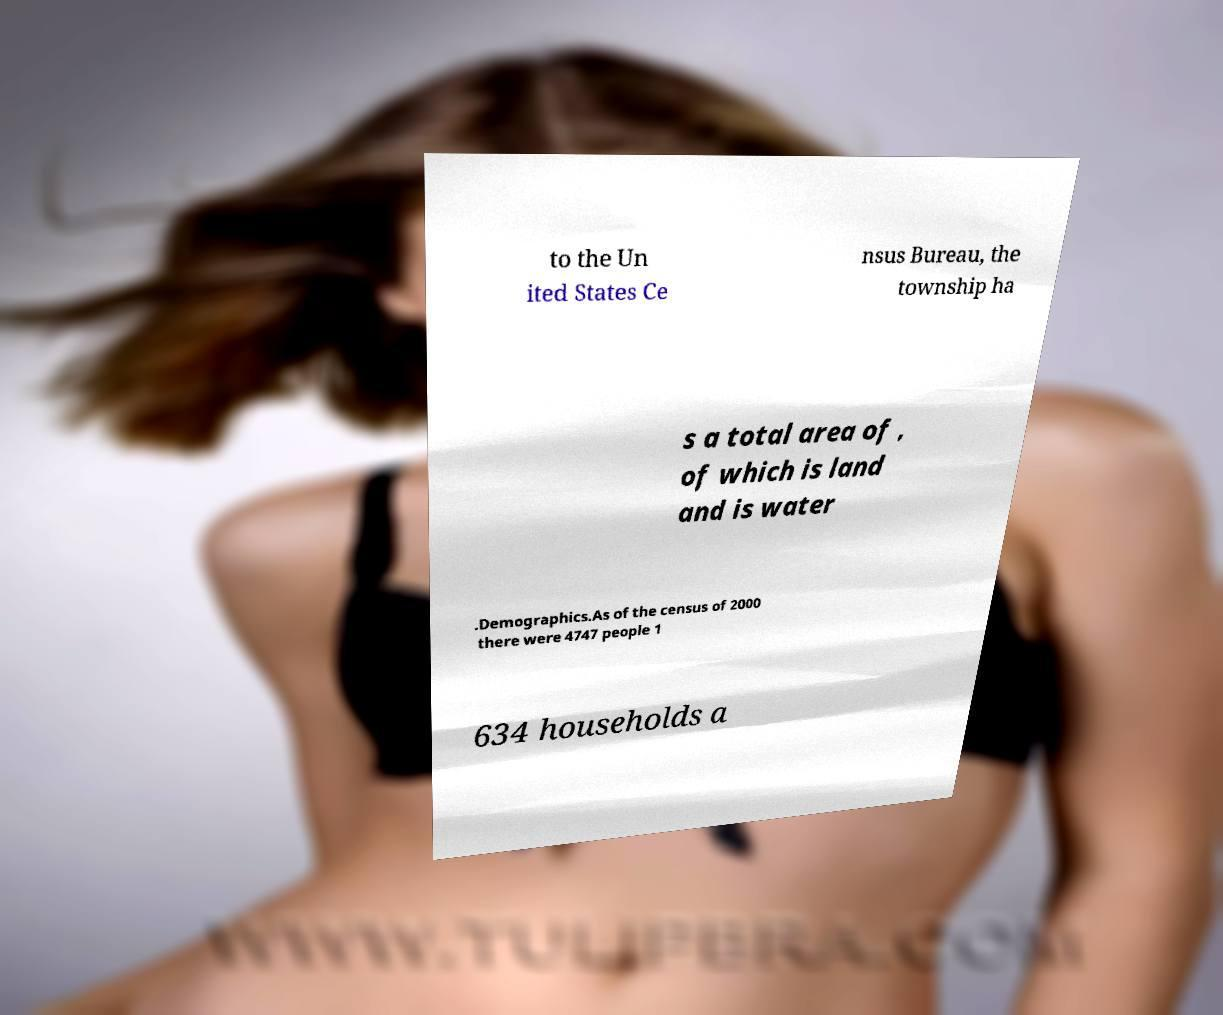Please identify and transcribe the text found in this image. to the Un ited States Ce nsus Bureau, the township ha s a total area of , of which is land and is water .Demographics.As of the census of 2000 there were 4747 people 1 634 households a 